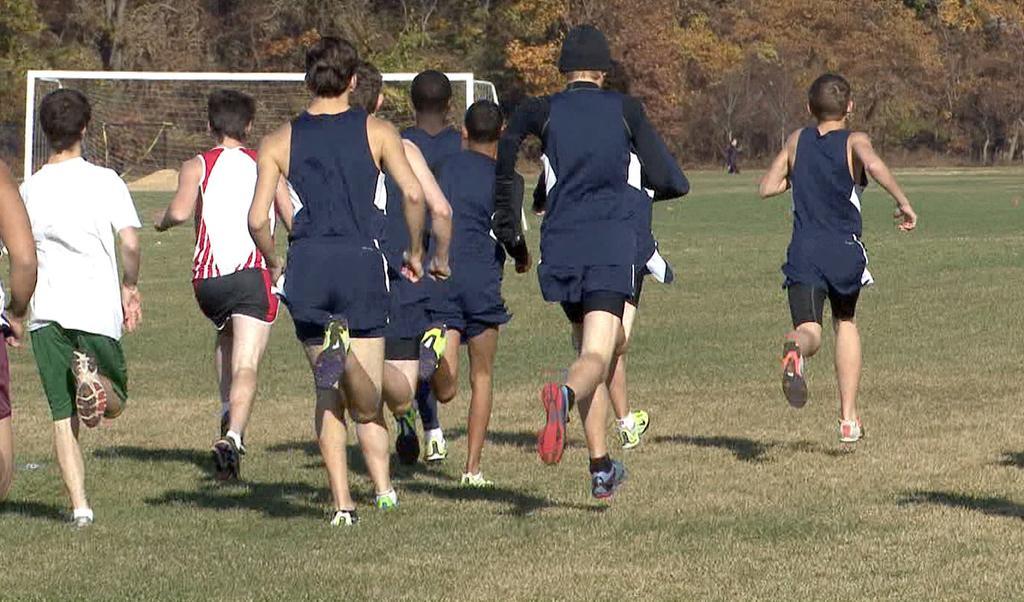Can you describe this image briefly? In this picture there are people running on the grass. In the background of the image we can see net and trees. 